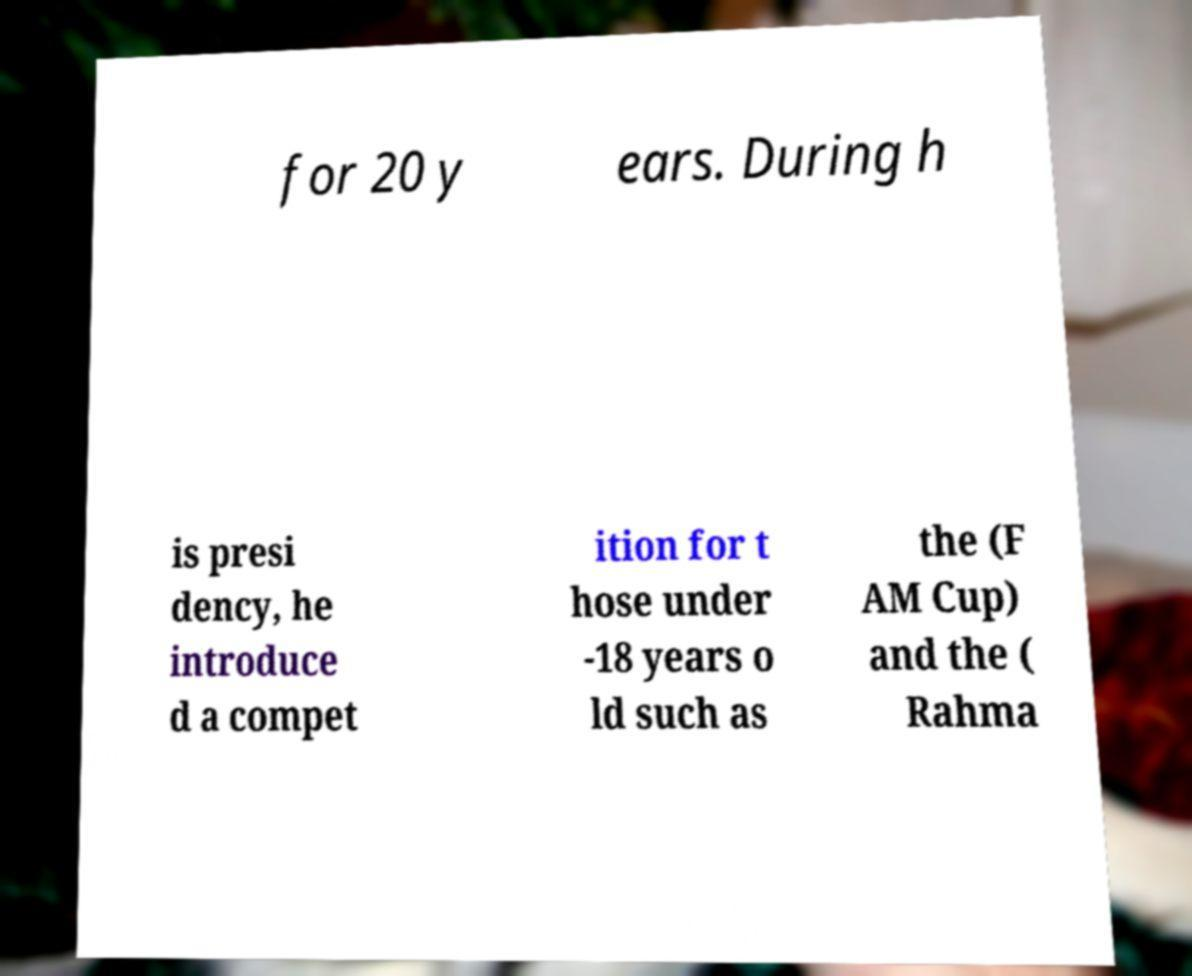For documentation purposes, I need the text within this image transcribed. Could you provide that? for 20 y ears. During h is presi dency, he introduce d a compet ition for t hose under -18 years o ld such as the (F AM Cup) and the ( Rahma 